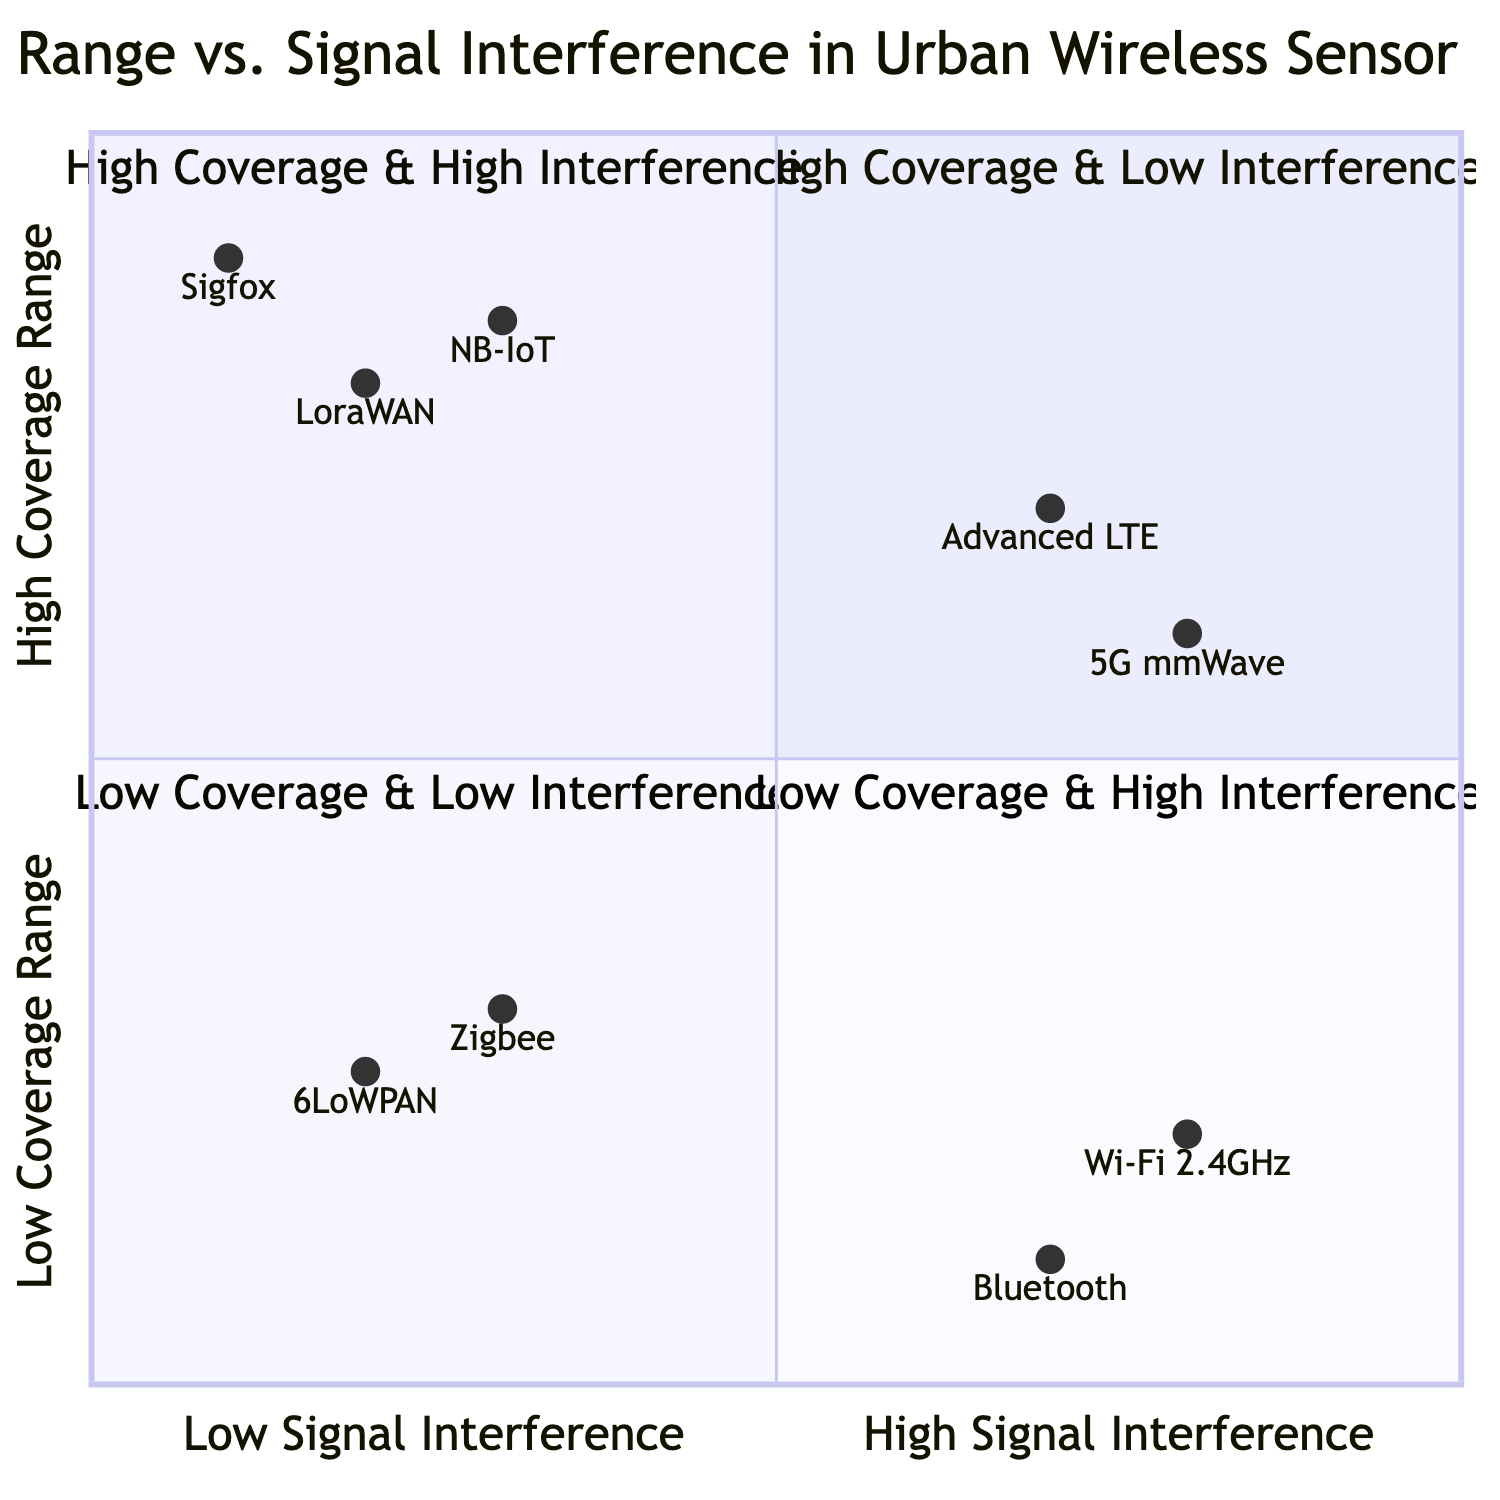What technologies are in the High Coverage & Low Interference quadrant? In the diagram, the technologies listed in the High Coverage & Low Interference quadrant include LoraWAN, Sigfox, and NB-IoT.
Answer: LoraWAN, Sigfox, NB-IoT Which quadrant has Advanced LTE? Advanced LTE is positioned in the High Coverage & High Interference quadrant, which indicates it offers good coverage but is influenced by significant interference.
Answer: High Coverage & High Interference What is the coverage range of Zigbee? Zigbee falls into the Low Coverage & Low Interference quadrant, where its coverage range is indicated as being low, specifically a coordinate of 0.3 on the coverage axis.
Answer: Low How many technologies are located in the Low Coverage & High Interference quadrant? The Low Coverage & High Interference quadrant contains two technologies: Wi-Fi (2.4 GHz) and Bluetooth. Therefore, the count of technologies in this quadrant is two.
Answer: 2 Which technology has the highest coverage range? Upon examining the diagram, NB-IoT has the highest coverage range in the High Coverage & Low Interference quadrant with a position corresponding to 0.85 on the coverage axis.
Answer: NB-IoT What is the signal interference level of 5G mmWave? 5G mmWave is represented within the High Coverage & High Interference quadrant, which indicates its signal interference level is high; specifically, it is located at 0.8 on the interference axis.
Answer: High In which quadrant is the technology Zigbee placed? Zigbee is located in the Low Coverage & Low Interference quadrant, which indicates it is optimized for localized communication with minimal interference.
Answer: Low Coverage & Low Interference Which technology suffers from the most signal interference? Among the depicted technologies, Wi-Fi (2.4 GHz) experiences the most signal interference as it is situated in the Low Coverage & High Interference quadrant.
Answer: Wi-Fi (2.4 GHz) 